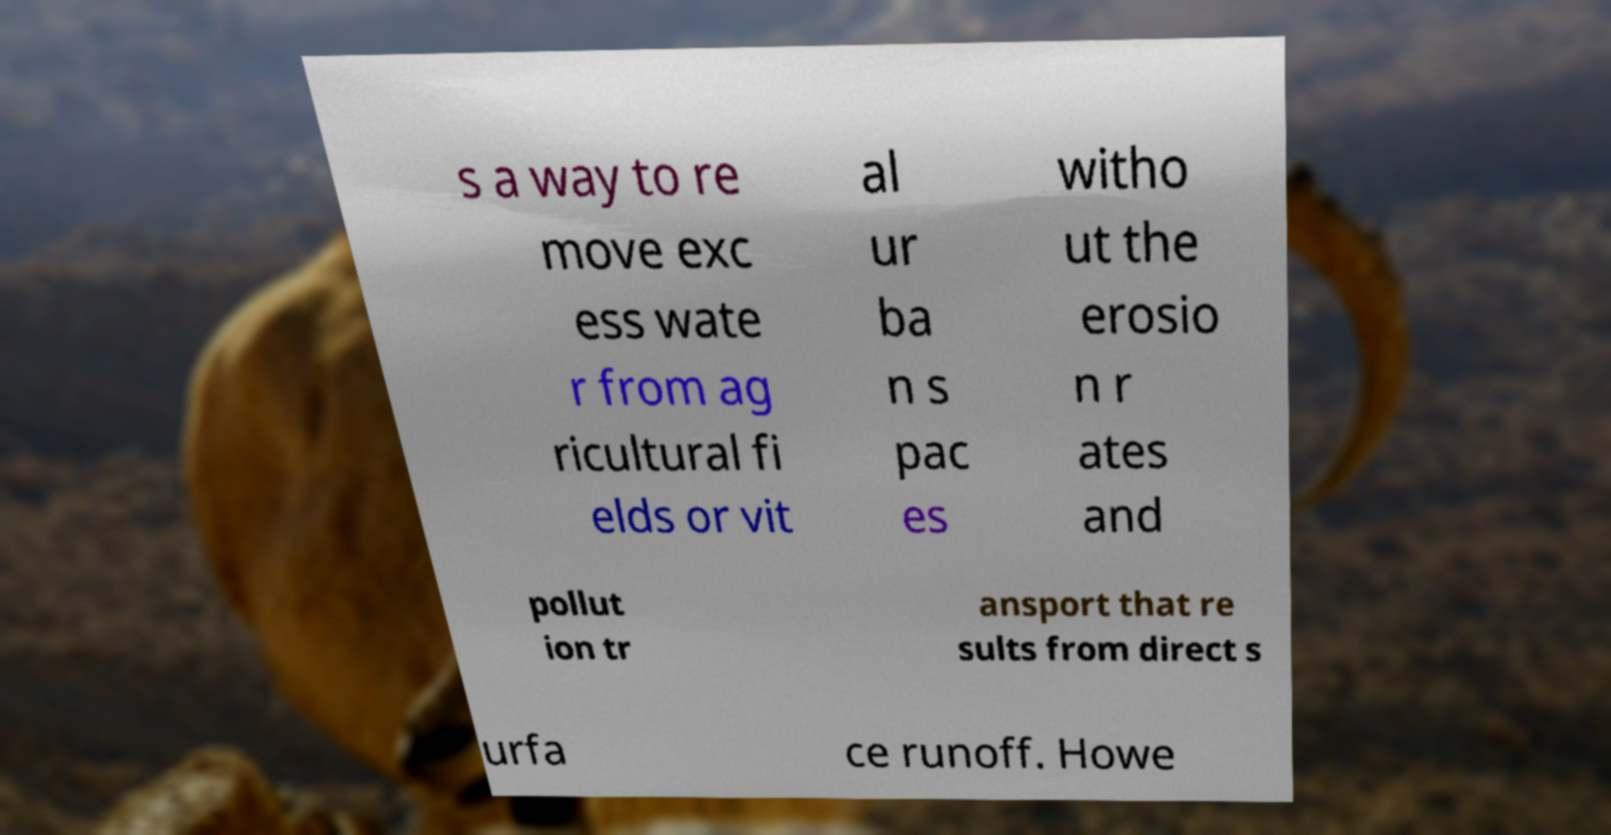What messages or text are displayed in this image? I need them in a readable, typed format. s a way to re move exc ess wate r from ag ricultural fi elds or vit al ur ba n s pac es witho ut the erosio n r ates and pollut ion tr ansport that re sults from direct s urfa ce runoff. Howe 